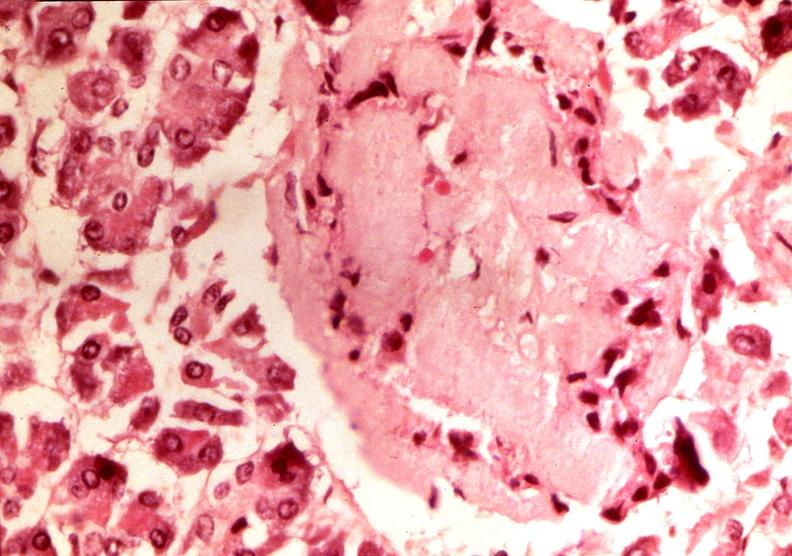what is present?
Answer the question using a single word or phrase. Endocrine 